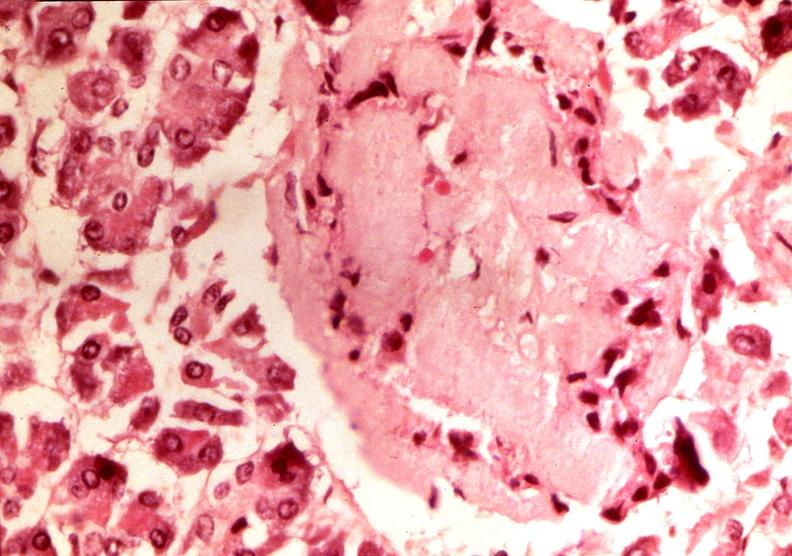what is present?
Answer the question using a single word or phrase. Endocrine 